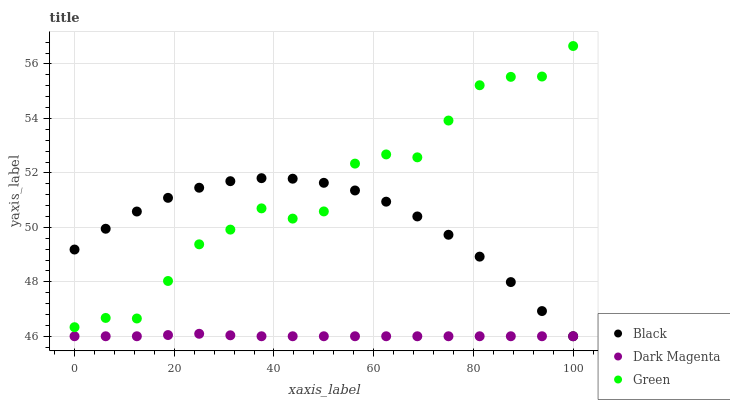Does Dark Magenta have the minimum area under the curve?
Answer yes or no. Yes. Does Green have the maximum area under the curve?
Answer yes or no. Yes. Does Black have the minimum area under the curve?
Answer yes or no. No. Does Black have the maximum area under the curve?
Answer yes or no. No. Is Dark Magenta the smoothest?
Answer yes or no. Yes. Is Green the roughest?
Answer yes or no. Yes. Is Black the smoothest?
Answer yes or no. No. Is Black the roughest?
Answer yes or no. No. Does Black have the lowest value?
Answer yes or no. Yes. Does Green have the highest value?
Answer yes or no. Yes. Does Black have the highest value?
Answer yes or no. No. Is Dark Magenta less than Green?
Answer yes or no. Yes. Is Green greater than Dark Magenta?
Answer yes or no. Yes. Does Dark Magenta intersect Black?
Answer yes or no. Yes. Is Dark Magenta less than Black?
Answer yes or no. No. Is Dark Magenta greater than Black?
Answer yes or no. No. Does Dark Magenta intersect Green?
Answer yes or no. No. 